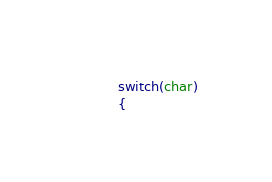<code> <loc_0><loc_0><loc_500><loc_500><_Haxe_>
		switch(char)
		{</code> 